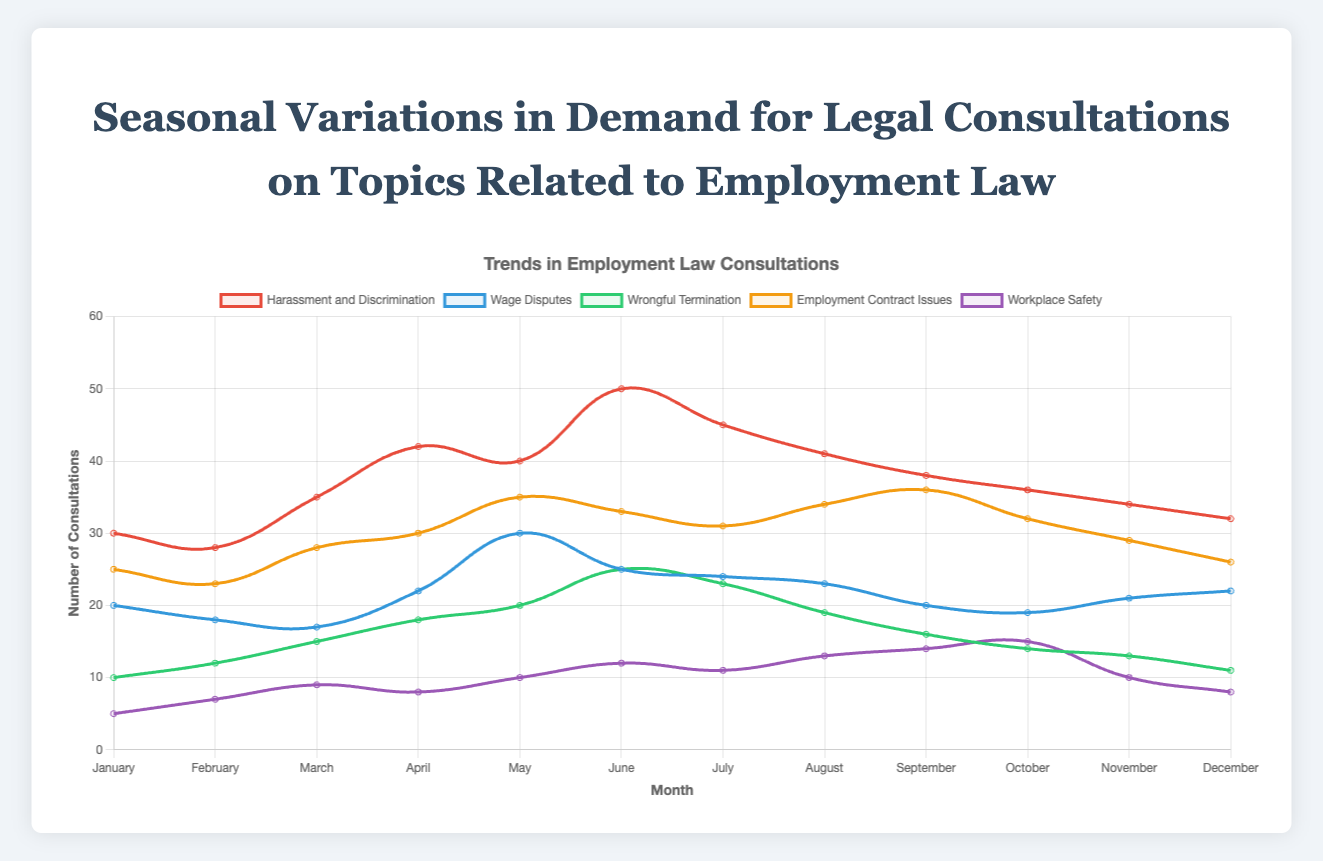When does "Harassment and Discrimination" have its peak consultations? Look for the highest point on the "Harassment and Discrimination" curve, which occurs in June.
Answer: June Which month has the lowest number of consultations for "Workplace Safety"? Identify the lowest point on the "Workplace Safety" line, which is in January.
Answer: January How does the demand for consultations for "Employment Contract Issues" in December compare to that in January? Compare the values for December and January on the "Employment Contract Issues" line, which are 26 and 25 respectively. December has slightly fewer consultations by 1.
Answer: Slightly fewer in December Which topic has the least variation in the number of consultations over the year? Assess the range of variation (difference between highest and lowest points) for each line. "Workplace Safety" ranges from 5 to 15. Comparatively, it has the least range.
Answer: Workplace Safety What is the average number of consultations for "Wrongful Termination" during the summer months (June, July, and August)? Sum of consultations for June (25), July (23), and August (19) is 67. The average is 67 divided by 3.
Answer: Average: 22.33 Which topic shows the most significant increase in consultations from April to May? Compare the increase for each topic between April and May. "Wage Disputes" increased from 22 to 30, a +8 increase, the highest among all topics.
Answer: Wage Disputes What color represents consultations related to "Harassment and Discrimination"? The color of the "Harassment and Discrimination" line is red.
Answer: Red Are consultations for "Wage Disputes" greater than or less than those for "Harassment and Discrimination" in August? Compare the values of both topics in August. "Wage Disputes" has 23 consultations, while "Harassment and Discrimination" has 41.
Answer: Less Which month has the highest consultations across all topics combined? Sum the consultations for all topics for each month, and find the month with the highest total. May has the highest combined consultations with sums: Harassment and Discrimination (40), Wage Disputes (30), Wrongful Termination (20), Employment Contract Issues (35), and Workplace Safety (10) making a total of 135.
Answer: May 